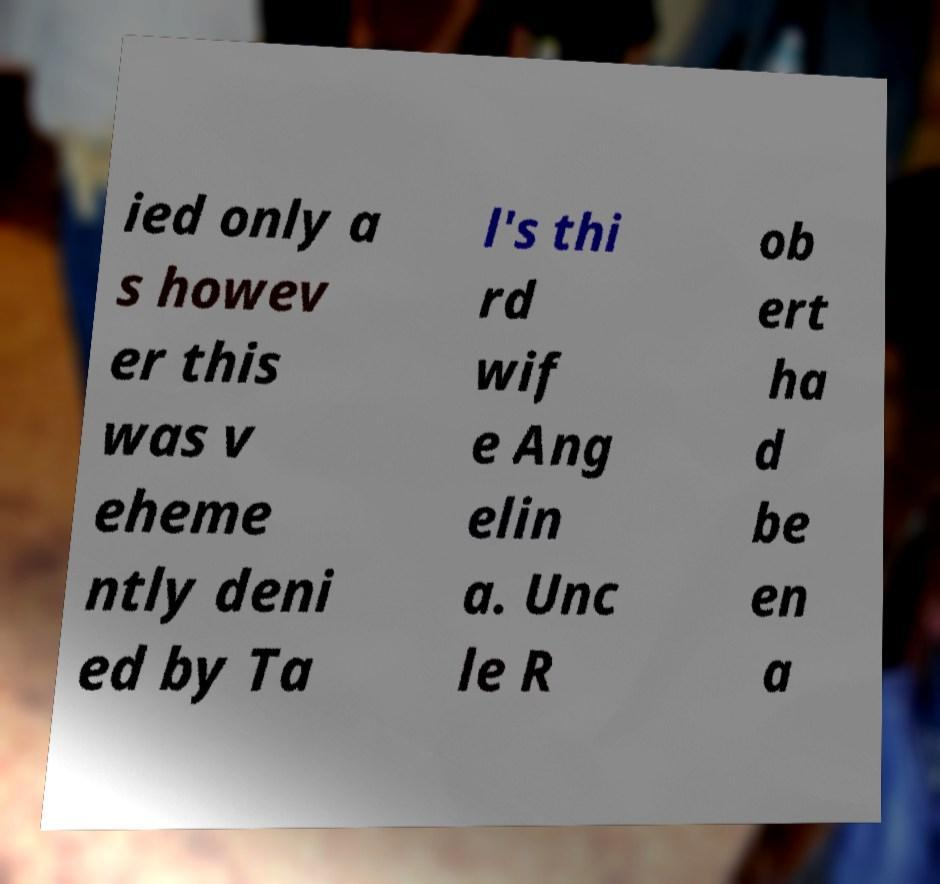Can you accurately transcribe the text from the provided image for me? ied only a s howev er this was v eheme ntly deni ed by Ta l's thi rd wif e Ang elin a. Unc le R ob ert ha d be en a 